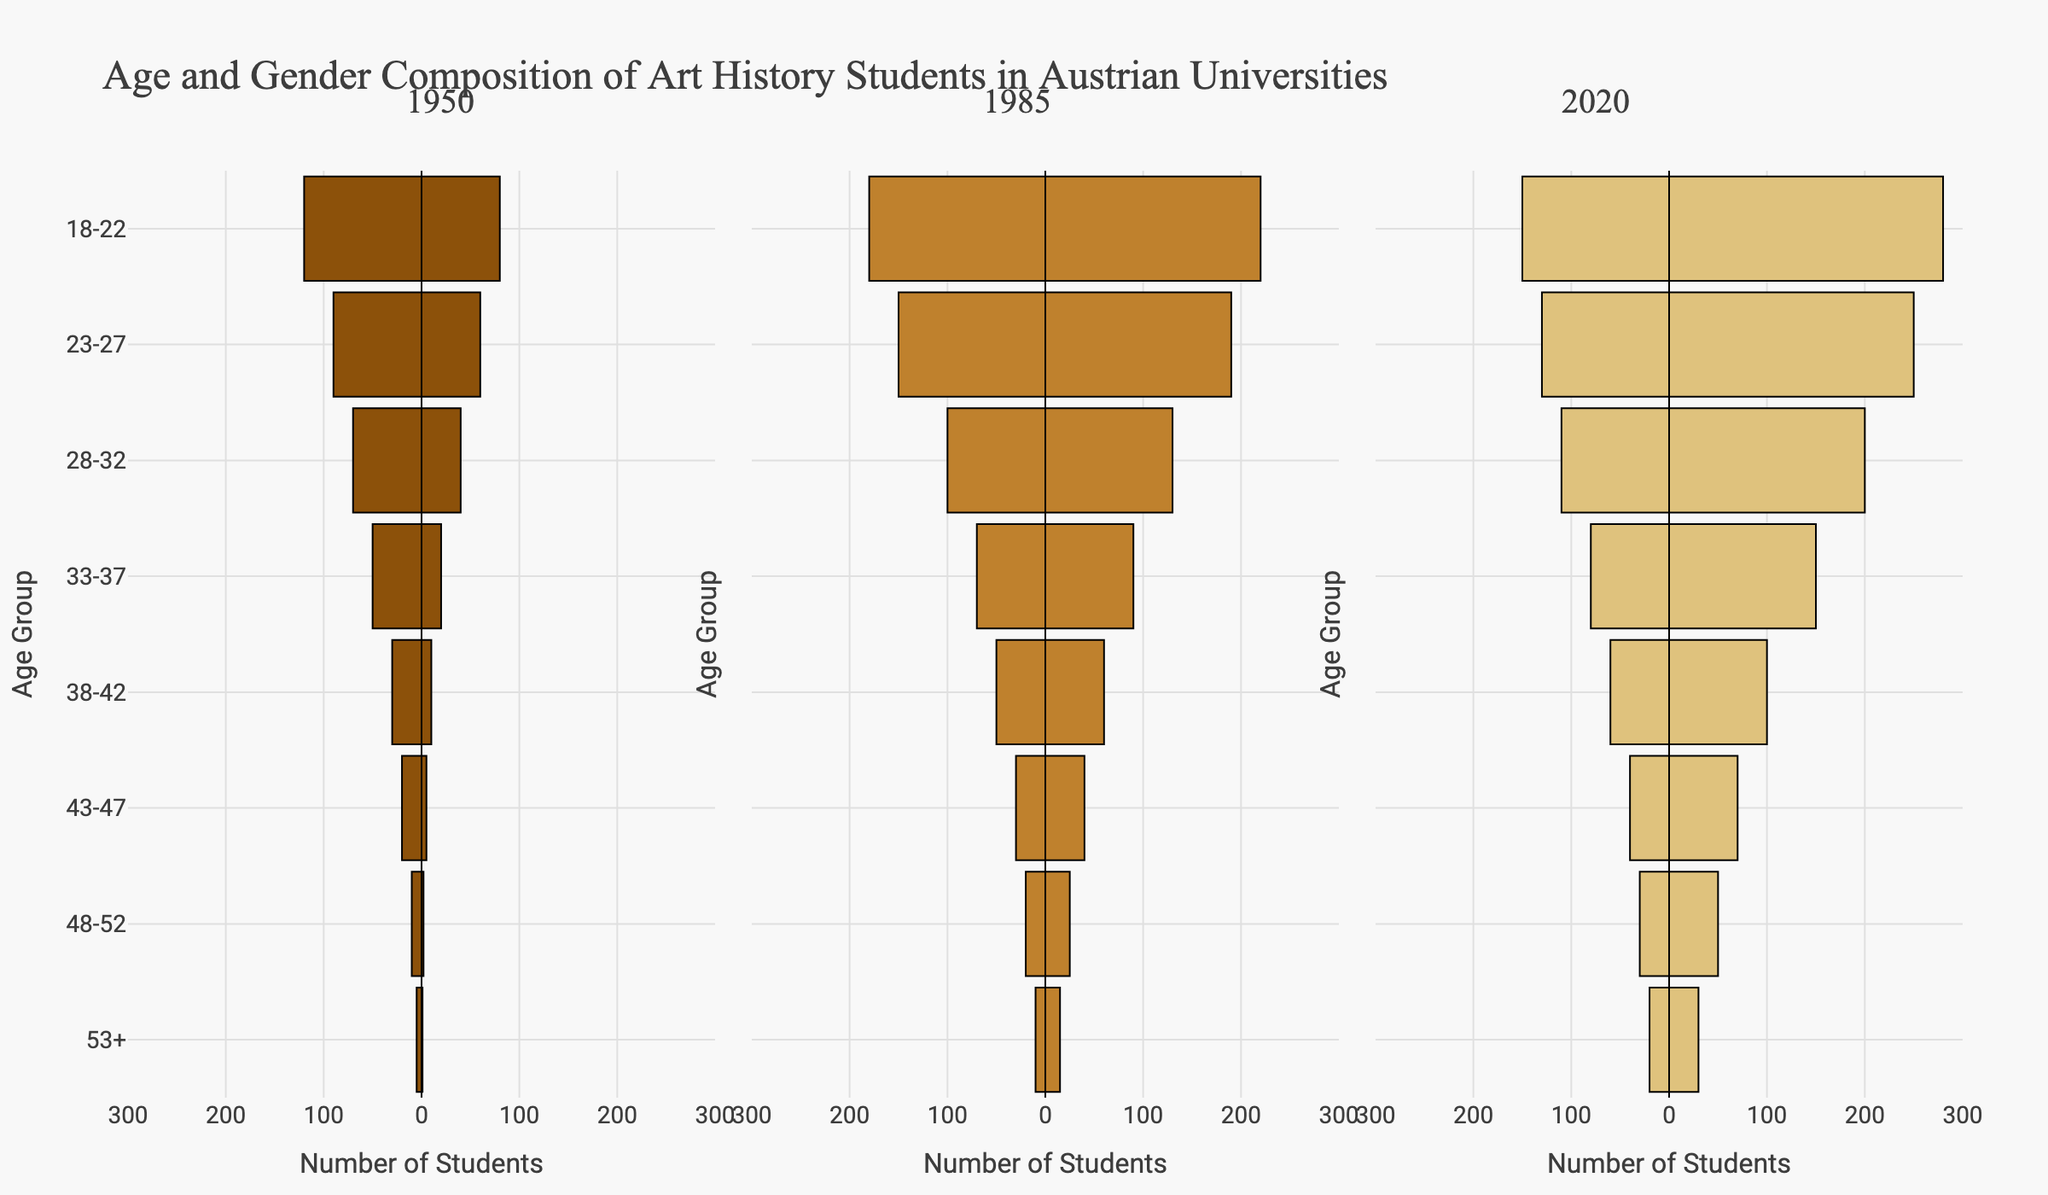How has the gender composition of art history students aged 18-22 changed from 1950 to 2020? In 1950, there were 120 male and 80 female students in the 18-22 age group. In 2020, there were 150 male and 280 female students. So, the number of male students decreased by 30, while the number of female students increased by 200.
Answer: Male decreased, Female increased What is the most noticeable change in the age distribution of female art history students between 1950 and 2020? In 1950, the highest number of female students was in the 18-22 age group (80). In 2020, the highest number was still in the 18-22 age group, but it increased significantly to 280. The most noticeable change is the large increase in female students aged 18-22.
Answer: Large increase in 18-22 age group Which year had the highest number of male art history students in the 23-27 age group? The year 1985 had the highest number of male students in the 23-27 age group with 150 students, compared to 90 in 1950 and 130 in 2020.
Answer: 1985 How did the number of male and female students in the 33-37 age group compare in 2020? In 2020, there were 80 male and 150 female students in the 33-37 age group. Female students (150) outnumbered male students (80) by 70.
Answer: Female students outnumbered male by 70 What trend can be observed in the number of art history students aged 53+ for both genders from 1950 to 2020? In 1950, there were 5 male and 1 female student aged 53+. By 2020, this increased to 20 males and 30 females. Both genders saw an increase in this age group, with a notable rise in female students.
Answer: Increase in both genders How many more female than male art history students were there in the 28-32 age group in 1985? In 1985, there were 100 male and 130 female students in the 28-32 age group. The number of female students exceeded male students by 30.
Answer: 30 more female students What proportion of art history students in the 43-47 age group were female in 1950? In 1950, there were 20 male and 5 female students in the 43-47 age group. The total number of students was 25. The proportion of female students was 5/25, which is 0.2 or 20%.
Answer: 20% Did the number of male students in the 48-52 age group increase or decrease from 1985 to 2020? In 1985, there were 20 male students in the 48-52 age group, whereas in 2020, there were 30 male students in the same group. Therefore, the number increased by 10.
Answer: Increase Which age group had the smallest number of students in each gender in 1950? In 1950, the age group with the smallest number of students for both genders was 53+, with 5 male and 1 female student.
Answer: 53+ 